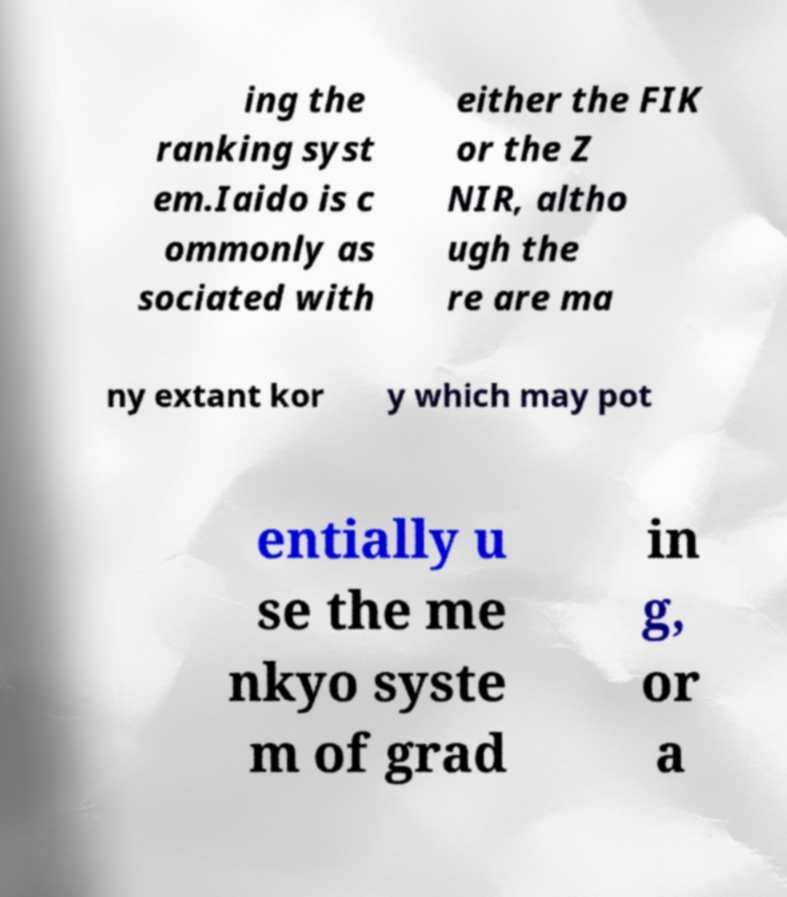For documentation purposes, I need the text within this image transcribed. Could you provide that? ing the ranking syst em.Iaido is c ommonly as sociated with either the FIK or the Z NIR, altho ugh the re are ma ny extant kor y which may pot entially u se the me nkyo syste m of grad in g, or a 